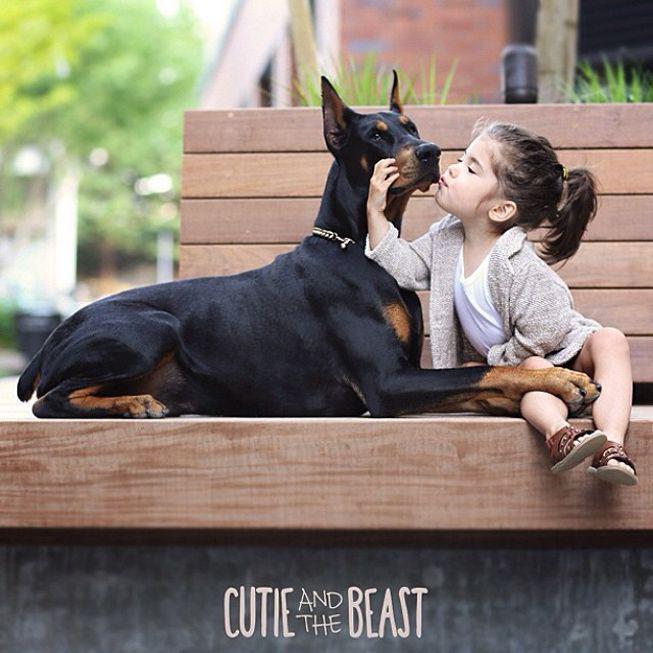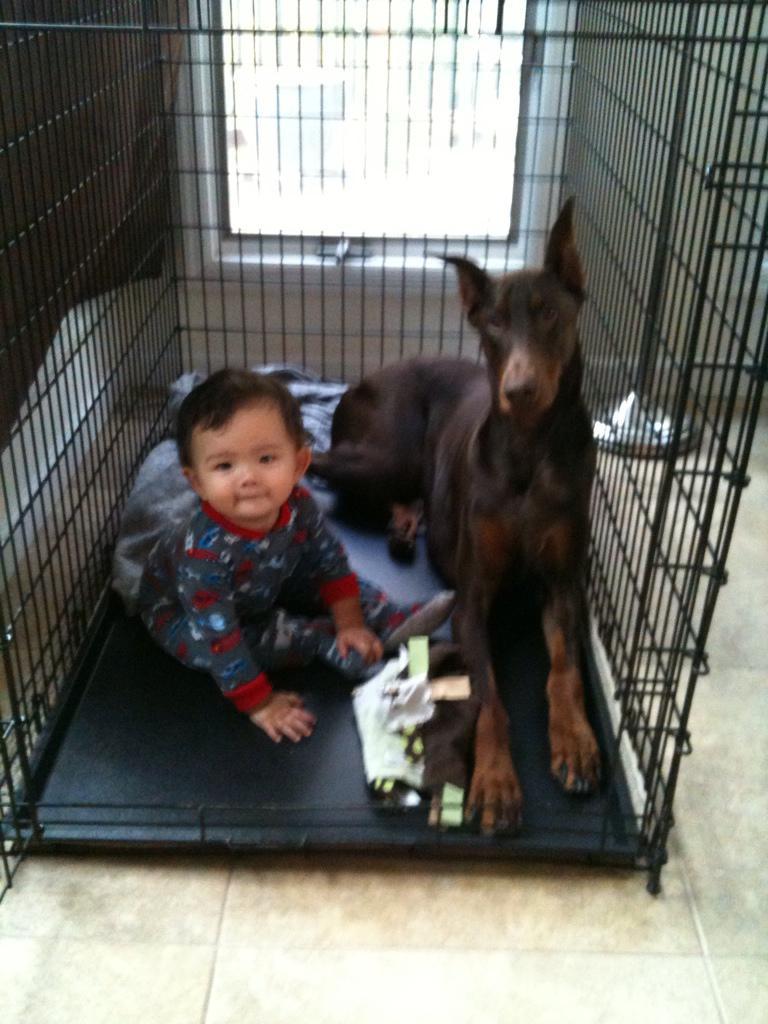The first image is the image on the left, the second image is the image on the right. Evaluate the accuracy of this statement regarding the images: "There are at least three dogs in total.". Is it true? Answer yes or no. No. The first image is the image on the left, the second image is the image on the right. For the images shown, is this caption "A young girl is sitting next to her doberman pincer." true? Answer yes or no. Yes. 